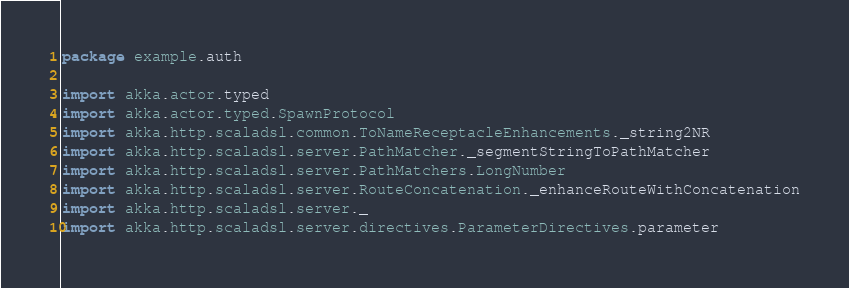Convert code to text. <code><loc_0><loc_0><loc_500><loc_500><_Scala_>package example.auth

import akka.actor.typed
import akka.actor.typed.SpawnProtocol
import akka.http.scaladsl.common.ToNameReceptacleEnhancements._string2NR
import akka.http.scaladsl.server.PathMatcher._segmentStringToPathMatcher
import akka.http.scaladsl.server.PathMatchers.LongNumber
import akka.http.scaladsl.server.RouteConcatenation._enhanceRouteWithConcatenation
import akka.http.scaladsl.server._
import akka.http.scaladsl.server.directives.ParameterDirectives.parameter</code> 